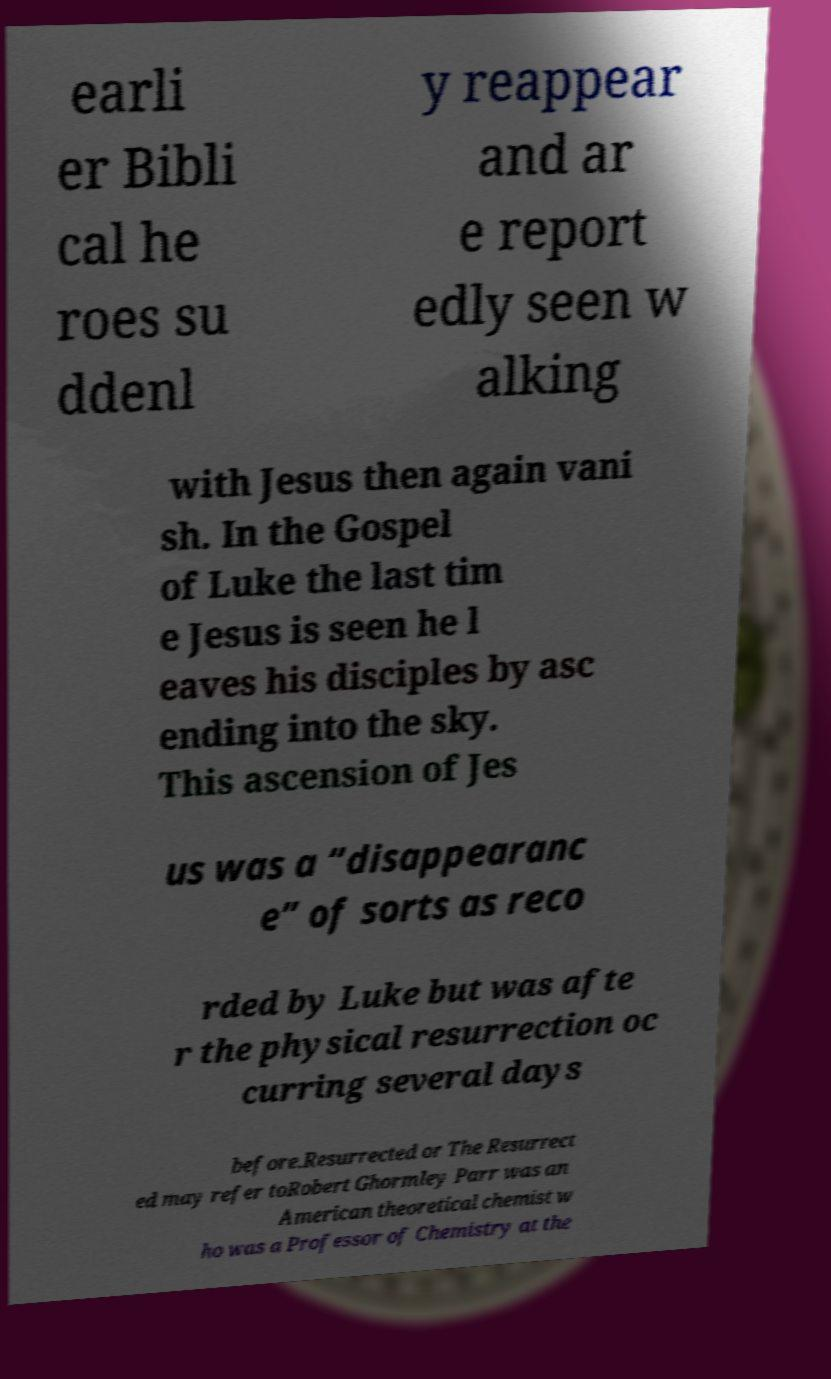Please read and relay the text visible in this image. What does it say? earli er Bibli cal he roes su ddenl y reappear and ar e report edly seen w alking with Jesus then again vani sh. In the Gospel of Luke the last tim e Jesus is seen he l eaves his disciples by asc ending into the sky. This ascension of Jes us was a “disappearanc e” of sorts as reco rded by Luke but was afte r the physical resurrection oc curring several days before.Resurrected or The Resurrect ed may refer toRobert Ghormley Parr was an American theoretical chemist w ho was a Professor of Chemistry at the 